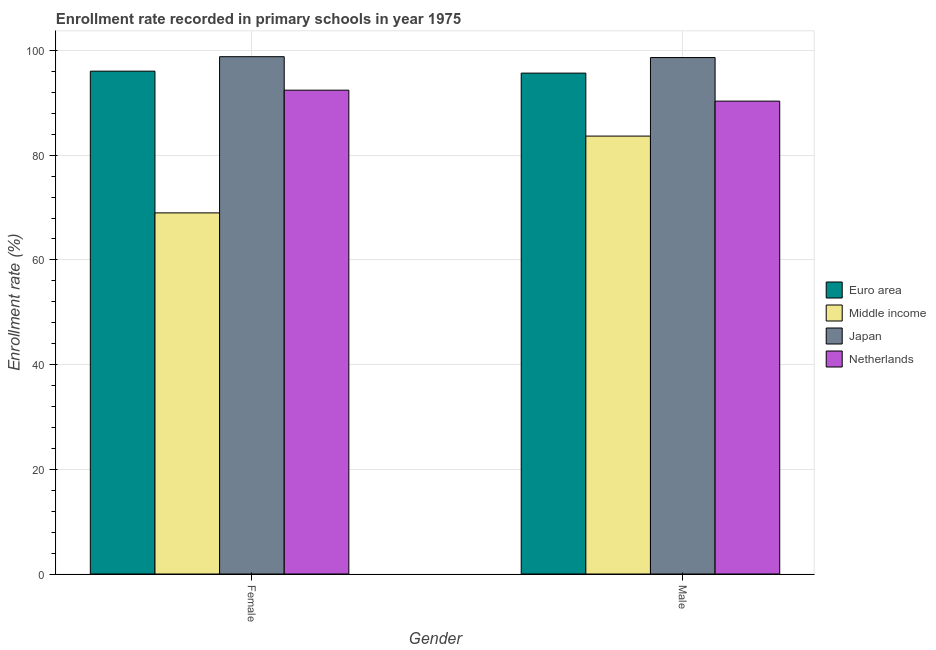How many groups of bars are there?
Offer a very short reply. 2. Are the number of bars on each tick of the X-axis equal?
Offer a very short reply. Yes. How many bars are there on the 2nd tick from the right?
Offer a terse response. 4. What is the label of the 2nd group of bars from the left?
Your response must be concise. Male. What is the enrollment rate of female students in Middle income?
Your response must be concise. 68.99. Across all countries, what is the maximum enrollment rate of male students?
Offer a very short reply. 98.66. Across all countries, what is the minimum enrollment rate of male students?
Keep it short and to the point. 83.66. What is the total enrollment rate of female students in the graph?
Provide a short and direct response. 356.3. What is the difference between the enrollment rate of female students in Japan and that in Middle income?
Ensure brevity in your answer.  29.84. What is the difference between the enrollment rate of female students in Middle income and the enrollment rate of male students in Netherlands?
Give a very brief answer. -21.35. What is the average enrollment rate of female students per country?
Your response must be concise. 89.07. What is the difference between the enrollment rate of female students and enrollment rate of male students in Japan?
Give a very brief answer. 0.16. What is the ratio of the enrollment rate of male students in Euro area to that in Middle income?
Offer a terse response. 1.14. Is the enrollment rate of female students in Euro area less than that in Japan?
Ensure brevity in your answer.  Yes. What does the 1st bar from the left in Female represents?
Offer a very short reply. Euro area. Are all the bars in the graph horizontal?
Your answer should be compact. No. What is the difference between two consecutive major ticks on the Y-axis?
Keep it short and to the point. 20. Are the values on the major ticks of Y-axis written in scientific E-notation?
Make the answer very short. No. Does the graph contain any zero values?
Offer a very short reply. No. Does the graph contain grids?
Keep it short and to the point. Yes. How many legend labels are there?
Your response must be concise. 4. How are the legend labels stacked?
Your answer should be very brief. Vertical. What is the title of the graph?
Keep it short and to the point. Enrollment rate recorded in primary schools in year 1975. Does "Lao PDR" appear as one of the legend labels in the graph?
Ensure brevity in your answer.  No. What is the label or title of the Y-axis?
Ensure brevity in your answer.  Enrollment rate (%). What is the Enrollment rate (%) of Euro area in Female?
Your answer should be very brief. 96.06. What is the Enrollment rate (%) in Middle income in Female?
Make the answer very short. 68.99. What is the Enrollment rate (%) in Japan in Female?
Your answer should be very brief. 98.82. What is the Enrollment rate (%) in Netherlands in Female?
Provide a short and direct response. 92.43. What is the Enrollment rate (%) of Euro area in Male?
Your response must be concise. 95.69. What is the Enrollment rate (%) in Middle income in Male?
Your answer should be very brief. 83.66. What is the Enrollment rate (%) in Japan in Male?
Your answer should be compact. 98.66. What is the Enrollment rate (%) in Netherlands in Male?
Your response must be concise. 90.34. Across all Gender, what is the maximum Enrollment rate (%) in Euro area?
Ensure brevity in your answer.  96.06. Across all Gender, what is the maximum Enrollment rate (%) in Middle income?
Provide a short and direct response. 83.66. Across all Gender, what is the maximum Enrollment rate (%) in Japan?
Your response must be concise. 98.82. Across all Gender, what is the maximum Enrollment rate (%) in Netherlands?
Your answer should be very brief. 92.43. Across all Gender, what is the minimum Enrollment rate (%) of Euro area?
Your response must be concise. 95.69. Across all Gender, what is the minimum Enrollment rate (%) of Middle income?
Provide a short and direct response. 68.99. Across all Gender, what is the minimum Enrollment rate (%) in Japan?
Your answer should be very brief. 98.66. Across all Gender, what is the minimum Enrollment rate (%) in Netherlands?
Ensure brevity in your answer.  90.34. What is the total Enrollment rate (%) in Euro area in the graph?
Make the answer very short. 191.75. What is the total Enrollment rate (%) of Middle income in the graph?
Make the answer very short. 152.64. What is the total Enrollment rate (%) of Japan in the graph?
Keep it short and to the point. 197.48. What is the total Enrollment rate (%) in Netherlands in the graph?
Your response must be concise. 182.76. What is the difference between the Enrollment rate (%) in Euro area in Female and that in Male?
Provide a short and direct response. 0.37. What is the difference between the Enrollment rate (%) of Middle income in Female and that in Male?
Offer a terse response. -14.67. What is the difference between the Enrollment rate (%) in Japan in Female and that in Male?
Keep it short and to the point. 0.16. What is the difference between the Enrollment rate (%) of Netherlands in Female and that in Male?
Offer a very short reply. 2.09. What is the difference between the Enrollment rate (%) of Euro area in Female and the Enrollment rate (%) of Middle income in Male?
Offer a very short reply. 12.4. What is the difference between the Enrollment rate (%) of Euro area in Female and the Enrollment rate (%) of Japan in Male?
Your answer should be compact. -2.6. What is the difference between the Enrollment rate (%) of Euro area in Female and the Enrollment rate (%) of Netherlands in Male?
Provide a short and direct response. 5.72. What is the difference between the Enrollment rate (%) in Middle income in Female and the Enrollment rate (%) in Japan in Male?
Your answer should be compact. -29.67. What is the difference between the Enrollment rate (%) of Middle income in Female and the Enrollment rate (%) of Netherlands in Male?
Offer a terse response. -21.35. What is the difference between the Enrollment rate (%) of Japan in Female and the Enrollment rate (%) of Netherlands in Male?
Offer a very short reply. 8.49. What is the average Enrollment rate (%) of Euro area per Gender?
Provide a succinct answer. 95.87. What is the average Enrollment rate (%) of Middle income per Gender?
Provide a succinct answer. 76.32. What is the average Enrollment rate (%) in Japan per Gender?
Give a very brief answer. 98.74. What is the average Enrollment rate (%) of Netherlands per Gender?
Make the answer very short. 91.38. What is the difference between the Enrollment rate (%) of Euro area and Enrollment rate (%) of Middle income in Female?
Provide a short and direct response. 27.07. What is the difference between the Enrollment rate (%) in Euro area and Enrollment rate (%) in Japan in Female?
Ensure brevity in your answer.  -2.77. What is the difference between the Enrollment rate (%) of Euro area and Enrollment rate (%) of Netherlands in Female?
Make the answer very short. 3.63. What is the difference between the Enrollment rate (%) of Middle income and Enrollment rate (%) of Japan in Female?
Provide a short and direct response. -29.84. What is the difference between the Enrollment rate (%) in Middle income and Enrollment rate (%) in Netherlands in Female?
Make the answer very short. -23.44. What is the difference between the Enrollment rate (%) of Japan and Enrollment rate (%) of Netherlands in Female?
Offer a very short reply. 6.4. What is the difference between the Enrollment rate (%) of Euro area and Enrollment rate (%) of Middle income in Male?
Offer a very short reply. 12.03. What is the difference between the Enrollment rate (%) of Euro area and Enrollment rate (%) of Japan in Male?
Provide a short and direct response. -2.97. What is the difference between the Enrollment rate (%) in Euro area and Enrollment rate (%) in Netherlands in Male?
Your answer should be very brief. 5.35. What is the difference between the Enrollment rate (%) in Middle income and Enrollment rate (%) in Japan in Male?
Keep it short and to the point. -15. What is the difference between the Enrollment rate (%) in Middle income and Enrollment rate (%) in Netherlands in Male?
Your answer should be very brief. -6.68. What is the difference between the Enrollment rate (%) in Japan and Enrollment rate (%) in Netherlands in Male?
Your response must be concise. 8.32. What is the ratio of the Enrollment rate (%) of Euro area in Female to that in Male?
Your answer should be very brief. 1. What is the ratio of the Enrollment rate (%) in Middle income in Female to that in Male?
Your answer should be very brief. 0.82. What is the ratio of the Enrollment rate (%) in Japan in Female to that in Male?
Your response must be concise. 1. What is the ratio of the Enrollment rate (%) of Netherlands in Female to that in Male?
Give a very brief answer. 1.02. What is the difference between the highest and the second highest Enrollment rate (%) in Euro area?
Ensure brevity in your answer.  0.37. What is the difference between the highest and the second highest Enrollment rate (%) of Middle income?
Ensure brevity in your answer.  14.67. What is the difference between the highest and the second highest Enrollment rate (%) of Japan?
Provide a short and direct response. 0.16. What is the difference between the highest and the second highest Enrollment rate (%) of Netherlands?
Provide a succinct answer. 2.09. What is the difference between the highest and the lowest Enrollment rate (%) of Euro area?
Your response must be concise. 0.37. What is the difference between the highest and the lowest Enrollment rate (%) in Middle income?
Make the answer very short. 14.67. What is the difference between the highest and the lowest Enrollment rate (%) of Japan?
Make the answer very short. 0.16. What is the difference between the highest and the lowest Enrollment rate (%) in Netherlands?
Ensure brevity in your answer.  2.09. 